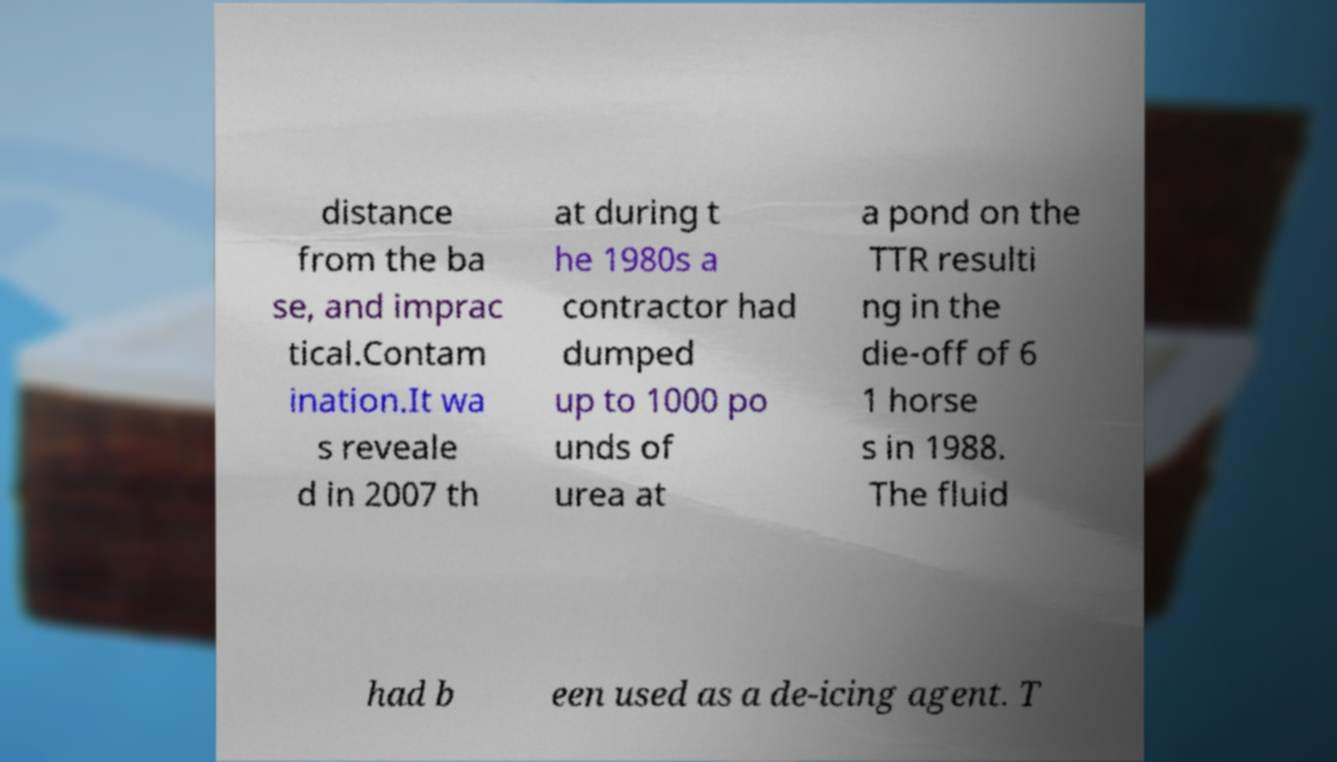There's text embedded in this image that I need extracted. Can you transcribe it verbatim? distance from the ba se, and imprac tical.Contam ination.It wa s reveale d in 2007 th at during t he 1980s a contractor had dumped up to 1000 po unds of urea at a pond on the TTR resulti ng in the die-off of 6 1 horse s in 1988. The fluid had b een used as a de-icing agent. T 